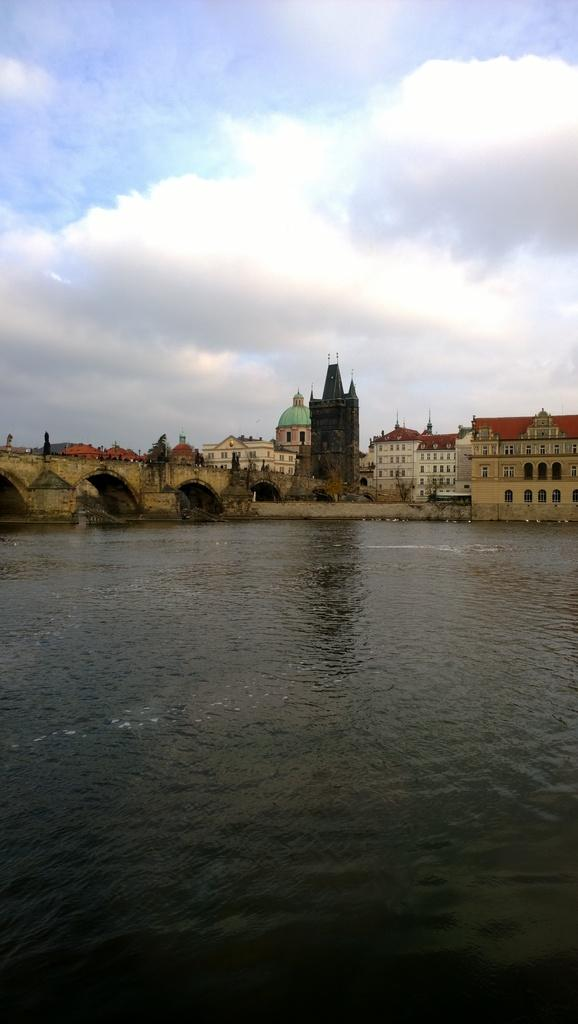What is the main feature of the image? The main feature of the image is a water surface. What can be seen in the distance from the water surface? There are tunnel ways visible in the distance. What structures are located near the tunnel ways? There are buildings near the tunnel ways. What is visible above the water surface and the tunnel ways? The sky is visible in the image. What can be observed in the sky? Clouds are present in the sky. What type of badge can be seen hanging from the tunnel ways in the image? There is no badge present in the image; it features a water surface, tunnel ways, buildings, and a sky with clouds. 